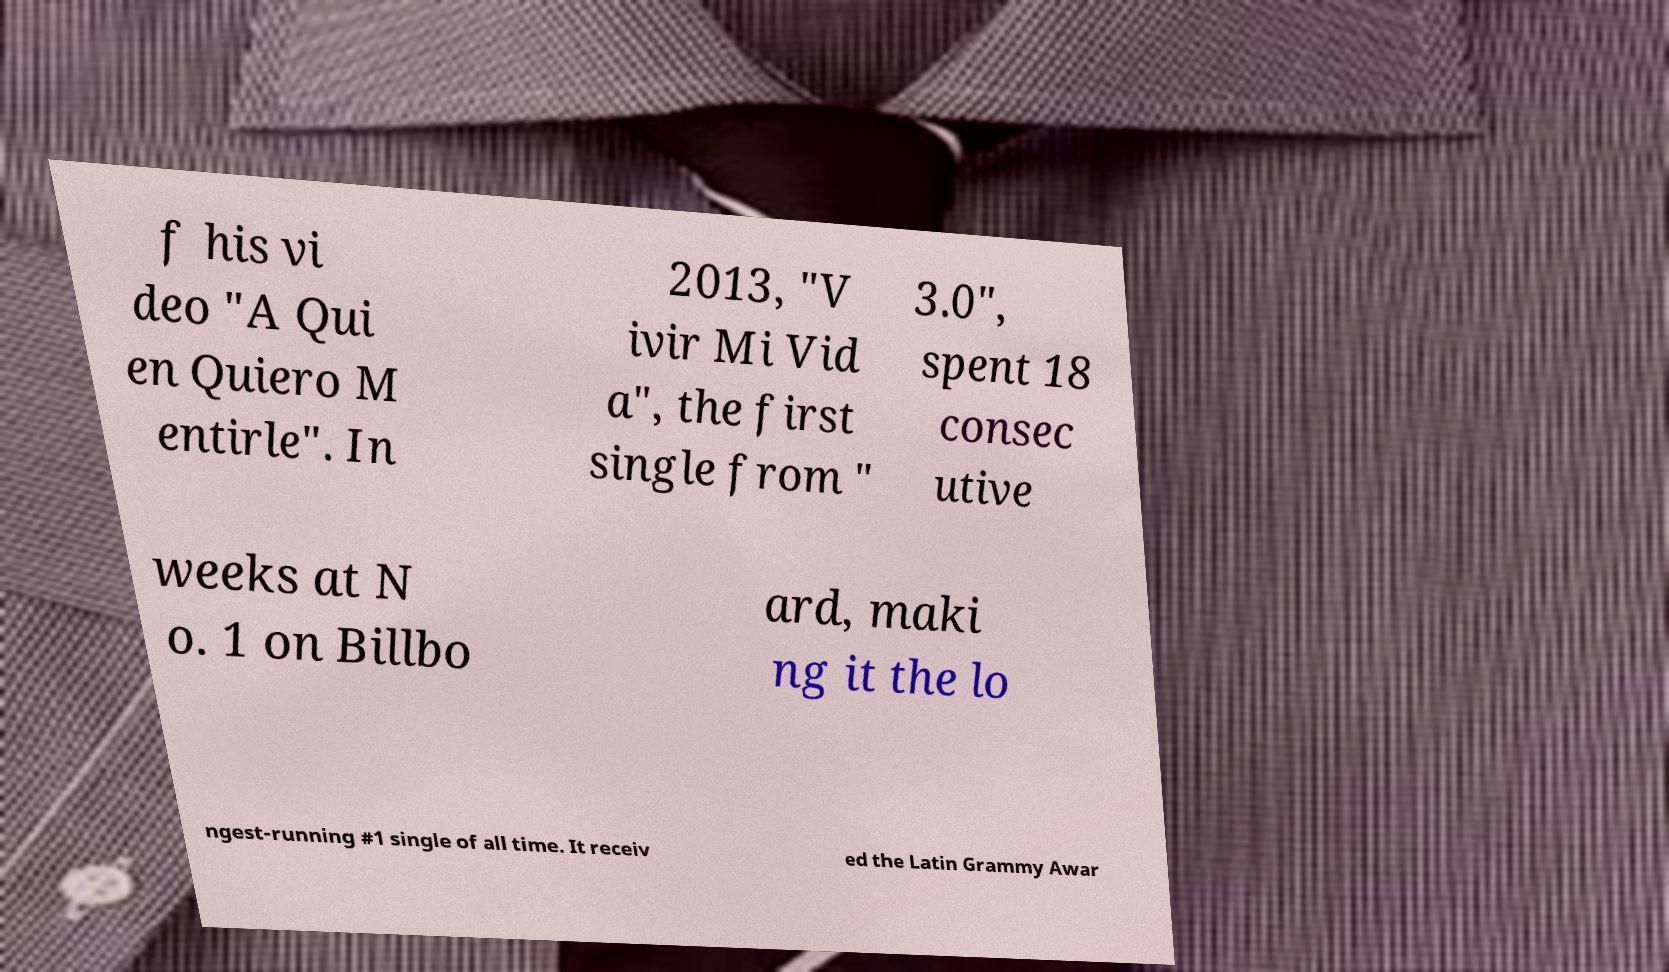I need the written content from this picture converted into text. Can you do that? f his vi deo "A Qui en Quiero M entirle". In 2013, "V ivir Mi Vid a", the first single from " 3.0", spent 18 consec utive weeks at N o. 1 on Billbo ard, maki ng it the lo ngest-running #1 single of all time. It receiv ed the Latin Grammy Awar 